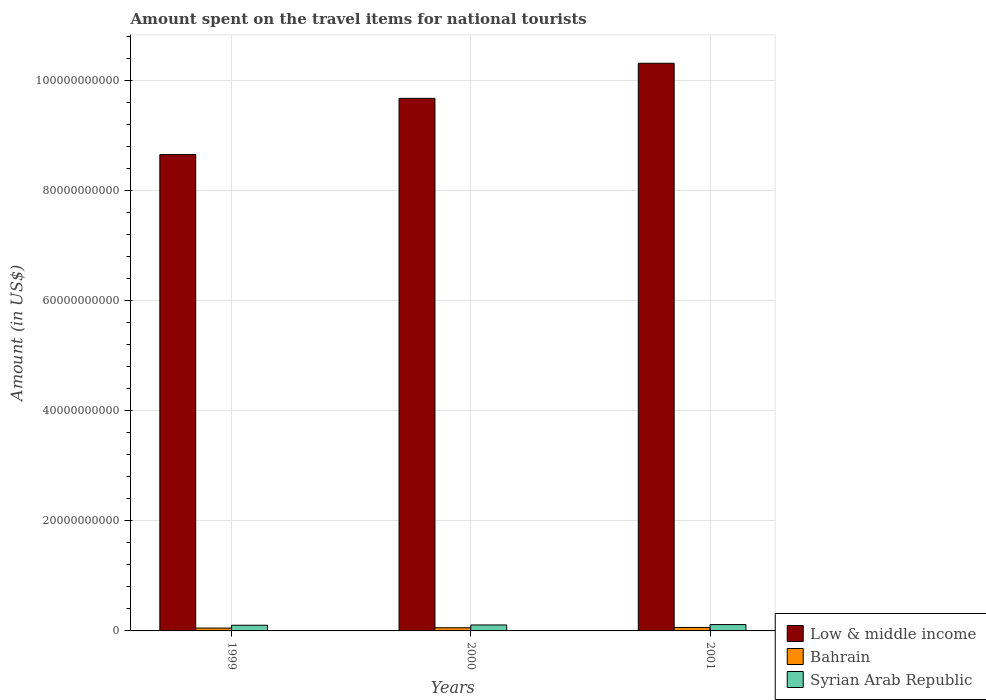What is the label of the 1st group of bars from the left?
Give a very brief answer. 1999. What is the amount spent on the travel items for national tourists in Low & middle income in 2001?
Keep it short and to the point. 1.03e+11. Across all years, what is the maximum amount spent on the travel items for national tourists in Syrian Arab Republic?
Your answer should be compact. 1.15e+09. Across all years, what is the minimum amount spent on the travel items for national tourists in Low & middle income?
Your answer should be compact. 8.66e+1. In which year was the amount spent on the travel items for national tourists in Low & middle income minimum?
Ensure brevity in your answer.  1999. What is the total amount spent on the travel items for national tourists in Low & middle income in the graph?
Your answer should be compact. 2.87e+11. What is the difference between the amount spent on the travel items for national tourists in Low & middle income in 1999 and that in 2001?
Provide a succinct answer. -1.66e+1. What is the difference between the amount spent on the travel items for national tourists in Low & middle income in 2001 and the amount spent on the travel items for national tourists in Bahrain in 1999?
Make the answer very short. 1.03e+11. What is the average amount spent on the travel items for national tourists in Syrian Arab Republic per year?
Give a very brief answer. 1.09e+09. In the year 2000, what is the difference between the amount spent on the travel items for national tourists in Bahrain and amount spent on the travel items for national tourists in Low & middle income?
Your response must be concise. -9.62e+1. What is the ratio of the amount spent on the travel items for national tourists in Bahrain in 1999 to that in 2000?
Provide a short and direct response. 0.9. Is the amount spent on the travel items for national tourists in Syrian Arab Republic in 1999 less than that in 2000?
Keep it short and to the point. Yes. Is the difference between the amount spent on the travel items for national tourists in Bahrain in 2000 and 2001 greater than the difference between the amount spent on the travel items for national tourists in Low & middle income in 2000 and 2001?
Ensure brevity in your answer.  Yes. What is the difference between the highest and the second highest amount spent on the travel items for national tourists in Syrian Arab Republic?
Ensure brevity in your answer.  6.80e+07. What is the difference between the highest and the lowest amount spent on the travel items for national tourists in Bahrain?
Keep it short and to the point. 1.12e+08. Is the sum of the amount spent on the travel items for national tourists in Low & middle income in 2000 and 2001 greater than the maximum amount spent on the travel items for national tourists in Syrian Arab Republic across all years?
Offer a terse response. Yes. What does the 2nd bar from the left in 2000 represents?
Your answer should be very brief. Bahrain. Are all the bars in the graph horizontal?
Offer a very short reply. No. How many years are there in the graph?
Provide a short and direct response. 3. What is the difference between two consecutive major ticks on the Y-axis?
Your answer should be compact. 2.00e+1. Are the values on the major ticks of Y-axis written in scientific E-notation?
Give a very brief answer. No. Does the graph contain any zero values?
Keep it short and to the point. No. Where does the legend appear in the graph?
Offer a terse response. Bottom right. How are the legend labels stacked?
Provide a succinct answer. Vertical. What is the title of the graph?
Offer a very short reply. Amount spent on the travel items for national tourists. Does "Europe(developing only)" appear as one of the legend labels in the graph?
Offer a terse response. No. What is the label or title of the X-axis?
Offer a very short reply. Years. What is the Amount (in US$) of Low & middle income in 1999?
Provide a short and direct response. 8.66e+1. What is the Amount (in US$) in Bahrain in 1999?
Your answer should be very brief. 5.18e+08. What is the Amount (in US$) of Syrian Arab Republic in 1999?
Give a very brief answer. 1.03e+09. What is the Amount (in US$) of Low & middle income in 2000?
Ensure brevity in your answer.  9.68e+1. What is the Amount (in US$) of Bahrain in 2000?
Your answer should be compact. 5.73e+08. What is the Amount (in US$) in Syrian Arab Republic in 2000?
Ensure brevity in your answer.  1.08e+09. What is the Amount (in US$) in Low & middle income in 2001?
Offer a very short reply. 1.03e+11. What is the Amount (in US$) in Bahrain in 2001?
Provide a short and direct response. 6.30e+08. What is the Amount (in US$) of Syrian Arab Republic in 2001?
Provide a short and direct response. 1.15e+09. Across all years, what is the maximum Amount (in US$) of Low & middle income?
Provide a short and direct response. 1.03e+11. Across all years, what is the maximum Amount (in US$) in Bahrain?
Your answer should be very brief. 6.30e+08. Across all years, what is the maximum Amount (in US$) of Syrian Arab Republic?
Offer a terse response. 1.15e+09. Across all years, what is the minimum Amount (in US$) of Low & middle income?
Your answer should be very brief. 8.66e+1. Across all years, what is the minimum Amount (in US$) in Bahrain?
Offer a terse response. 5.18e+08. Across all years, what is the minimum Amount (in US$) in Syrian Arab Republic?
Provide a short and direct response. 1.03e+09. What is the total Amount (in US$) of Low & middle income in the graph?
Your answer should be very brief. 2.87e+11. What is the total Amount (in US$) in Bahrain in the graph?
Your response must be concise. 1.72e+09. What is the total Amount (in US$) in Syrian Arab Republic in the graph?
Offer a very short reply. 3.26e+09. What is the difference between the Amount (in US$) in Low & middle income in 1999 and that in 2000?
Your answer should be very brief. -1.02e+1. What is the difference between the Amount (in US$) in Bahrain in 1999 and that in 2000?
Keep it short and to the point. -5.50e+07. What is the difference between the Amount (in US$) of Syrian Arab Republic in 1999 and that in 2000?
Provide a succinct answer. -5.10e+07. What is the difference between the Amount (in US$) in Low & middle income in 1999 and that in 2001?
Ensure brevity in your answer.  -1.66e+1. What is the difference between the Amount (in US$) in Bahrain in 1999 and that in 2001?
Provide a succinct answer. -1.12e+08. What is the difference between the Amount (in US$) in Syrian Arab Republic in 1999 and that in 2001?
Your answer should be compact. -1.19e+08. What is the difference between the Amount (in US$) in Low & middle income in 2000 and that in 2001?
Ensure brevity in your answer.  -6.38e+09. What is the difference between the Amount (in US$) of Bahrain in 2000 and that in 2001?
Make the answer very short. -5.70e+07. What is the difference between the Amount (in US$) of Syrian Arab Republic in 2000 and that in 2001?
Provide a short and direct response. -6.80e+07. What is the difference between the Amount (in US$) of Low & middle income in 1999 and the Amount (in US$) of Bahrain in 2000?
Provide a succinct answer. 8.60e+1. What is the difference between the Amount (in US$) of Low & middle income in 1999 and the Amount (in US$) of Syrian Arab Republic in 2000?
Provide a short and direct response. 8.55e+1. What is the difference between the Amount (in US$) of Bahrain in 1999 and the Amount (in US$) of Syrian Arab Republic in 2000?
Make the answer very short. -5.64e+08. What is the difference between the Amount (in US$) in Low & middle income in 1999 and the Amount (in US$) in Bahrain in 2001?
Your response must be concise. 8.59e+1. What is the difference between the Amount (in US$) in Low & middle income in 1999 and the Amount (in US$) in Syrian Arab Republic in 2001?
Your answer should be compact. 8.54e+1. What is the difference between the Amount (in US$) in Bahrain in 1999 and the Amount (in US$) in Syrian Arab Republic in 2001?
Keep it short and to the point. -6.32e+08. What is the difference between the Amount (in US$) of Low & middle income in 2000 and the Amount (in US$) of Bahrain in 2001?
Your answer should be very brief. 9.62e+1. What is the difference between the Amount (in US$) in Low & middle income in 2000 and the Amount (in US$) in Syrian Arab Republic in 2001?
Keep it short and to the point. 9.56e+1. What is the difference between the Amount (in US$) of Bahrain in 2000 and the Amount (in US$) of Syrian Arab Republic in 2001?
Make the answer very short. -5.77e+08. What is the average Amount (in US$) of Low & middle income per year?
Offer a terse response. 9.55e+1. What is the average Amount (in US$) in Bahrain per year?
Give a very brief answer. 5.74e+08. What is the average Amount (in US$) in Syrian Arab Republic per year?
Your response must be concise. 1.09e+09. In the year 1999, what is the difference between the Amount (in US$) in Low & middle income and Amount (in US$) in Bahrain?
Your response must be concise. 8.61e+1. In the year 1999, what is the difference between the Amount (in US$) of Low & middle income and Amount (in US$) of Syrian Arab Republic?
Your response must be concise. 8.55e+1. In the year 1999, what is the difference between the Amount (in US$) of Bahrain and Amount (in US$) of Syrian Arab Republic?
Provide a short and direct response. -5.13e+08. In the year 2000, what is the difference between the Amount (in US$) of Low & middle income and Amount (in US$) of Bahrain?
Your answer should be compact. 9.62e+1. In the year 2000, what is the difference between the Amount (in US$) in Low & middle income and Amount (in US$) in Syrian Arab Republic?
Provide a succinct answer. 9.57e+1. In the year 2000, what is the difference between the Amount (in US$) of Bahrain and Amount (in US$) of Syrian Arab Republic?
Offer a terse response. -5.09e+08. In the year 2001, what is the difference between the Amount (in US$) of Low & middle income and Amount (in US$) of Bahrain?
Provide a short and direct response. 1.03e+11. In the year 2001, what is the difference between the Amount (in US$) of Low & middle income and Amount (in US$) of Syrian Arab Republic?
Make the answer very short. 1.02e+11. In the year 2001, what is the difference between the Amount (in US$) of Bahrain and Amount (in US$) of Syrian Arab Republic?
Make the answer very short. -5.20e+08. What is the ratio of the Amount (in US$) in Low & middle income in 1999 to that in 2000?
Your answer should be very brief. 0.89. What is the ratio of the Amount (in US$) in Bahrain in 1999 to that in 2000?
Ensure brevity in your answer.  0.9. What is the ratio of the Amount (in US$) in Syrian Arab Republic in 1999 to that in 2000?
Offer a terse response. 0.95. What is the ratio of the Amount (in US$) in Low & middle income in 1999 to that in 2001?
Offer a terse response. 0.84. What is the ratio of the Amount (in US$) of Bahrain in 1999 to that in 2001?
Your answer should be very brief. 0.82. What is the ratio of the Amount (in US$) in Syrian Arab Republic in 1999 to that in 2001?
Give a very brief answer. 0.9. What is the ratio of the Amount (in US$) of Low & middle income in 2000 to that in 2001?
Ensure brevity in your answer.  0.94. What is the ratio of the Amount (in US$) in Bahrain in 2000 to that in 2001?
Your response must be concise. 0.91. What is the ratio of the Amount (in US$) in Syrian Arab Republic in 2000 to that in 2001?
Your answer should be very brief. 0.94. What is the difference between the highest and the second highest Amount (in US$) of Low & middle income?
Give a very brief answer. 6.38e+09. What is the difference between the highest and the second highest Amount (in US$) in Bahrain?
Provide a short and direct response. 5.70e+07. What is the difference between the highest and the second highest Amount (in US$) of Syrian Arab Republic?
Provide a succinct answer. 6.80e+07. What is the difference between the highest and the lowest Amount (in US$) of Low & middle income?
Ensure brevity in your answer.  1.66e+1. What is the difference between the highest and the lowest Amount (in US$) of Bahrain?
Offer a very short reply. 1.12e+08. What is the difference between the highest and the lowest Amount (in US$) in Syrian Arab Republic?
Your answer should be compact. 1.19e+08. 